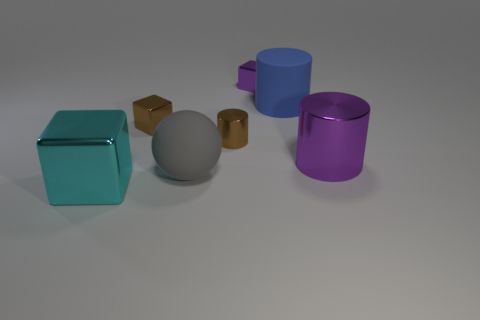Is there any other thing that has the same shape as the gray object?
Your answer should be very brief. No. Are there any small cubes?
Make the answer very short. Yes. Is the cylinder that is right of the large blue thing made of the same material as the cylinder left of the tiny purple metallic thing?
Your answer should be very brief. Yes. There is a brown block that is to the left of the purple shiny object that is on the right side of the metal object that is behind the large blue rubber thing; what size is it?
Your answer should be compact. Small. How many big cyan things have the same material as the gray thing?
Give a very brief answer. 0. Are there fewer small green balls than metallic things?
Make the answer very short. Yes. What is the size of the brown object that is the same shape as the blue thing?
Your answer should be very brief. Small. Does the big object behind the large purple cylinder have the same material as the ball?
Make the answer very short. Yes. Is the large gray matte thing the same shape as the small purple thing?
Provide a succinct answer. No. What number of objects are big metallic things that are left of the big purple cylinder or big red metal things?
Keep it short and to the point. 1. 